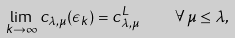<formula> <loc_0><loc_0><loc_500><loc_500>\lim _ { k \rightarrow \infty } c _ { \lambda , \mu } ( \epsilon _ { k } ) = c _ { \lambda , \mu } ^ { L } \quad \forall \, \mu \leq \lambda ,</formula> 